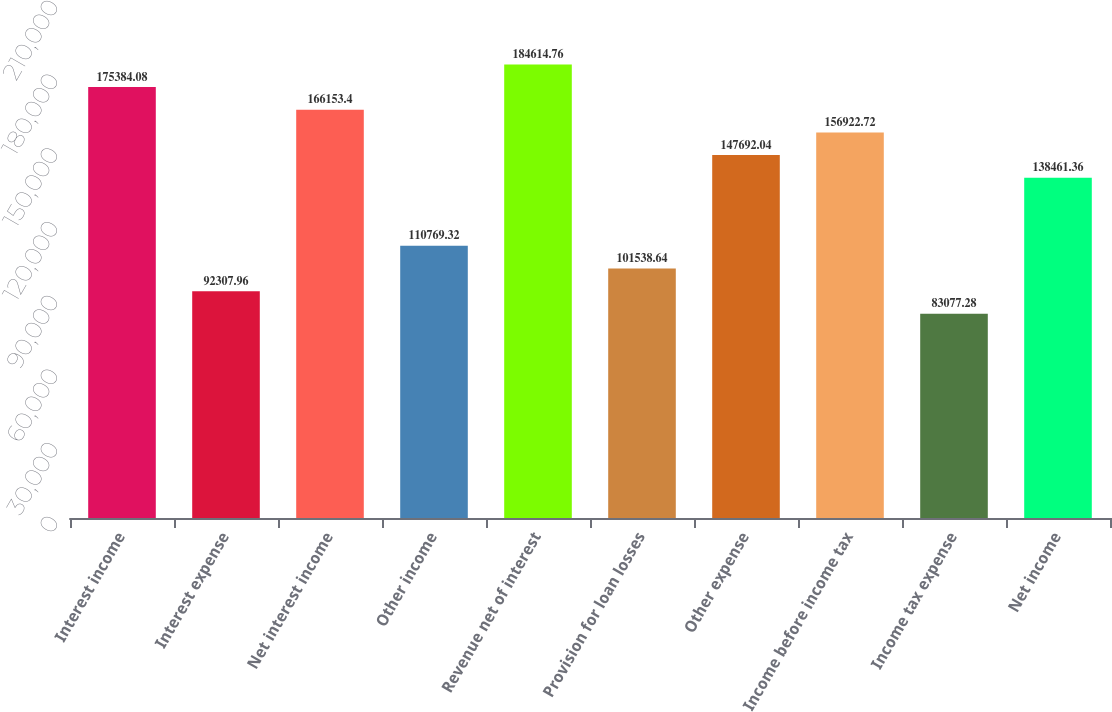Convert chart to OTSL. <chart><loc_0><loc_0><loc_500><loc_500><bar_chart><fcel>Interest income<fcel>Interest expense<fcel>Net interest income<fcel>Other income<fcel>Revenue net of interest<fcel>Provision for loan losses<fcel>Other expense<fcel>Income before income tax<fcel>Income tax expense<fcel>Net income<nl><fcel>175384<fcel>92308<fcel>166153<fcel>110769<fcel>184615<fcel>101539<fcel>147692<fcel>156923<fcel>83077.3<fcel>138461<nl></chart> 